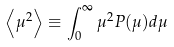<formula> <loc_0><loc_0><loc_500><loc_500>\left < \mu ^ { 2 } \right > \equiv \int _ { 0 } ^ { \infty } \mu ^ { 2 } P ( \mu ) d \mu</formula> 